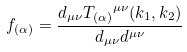<formula> <loc_0><loc_0><loc_500><loc_500>f _ { ( \alpha ) } = \frac { d _ { \mu \nu } { T _ { ( \alpha ) } } ^ { \mu \nu } ( k _ { 1 } , k _ { 2 } ) } { d _ { \mu \nu } d ^ { \mu \nu } }</formula> 